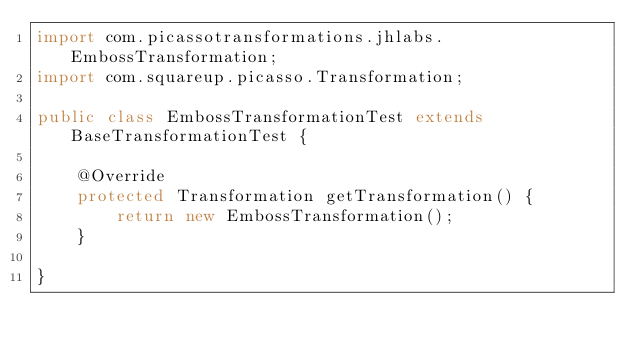<code> <loc_0><loc_0><loc_500><loc_500><_Java_>import com.picassotransformations.jhlabs.EmbossTransformation;
import com.squareup.picasso.Transformation;

public class EmbossTransformationTest extends BaseTransformationTest {

    @Override
    protected Transformation getTransformation() {
        return new EmbossTransformation();
    }

}
</code> 